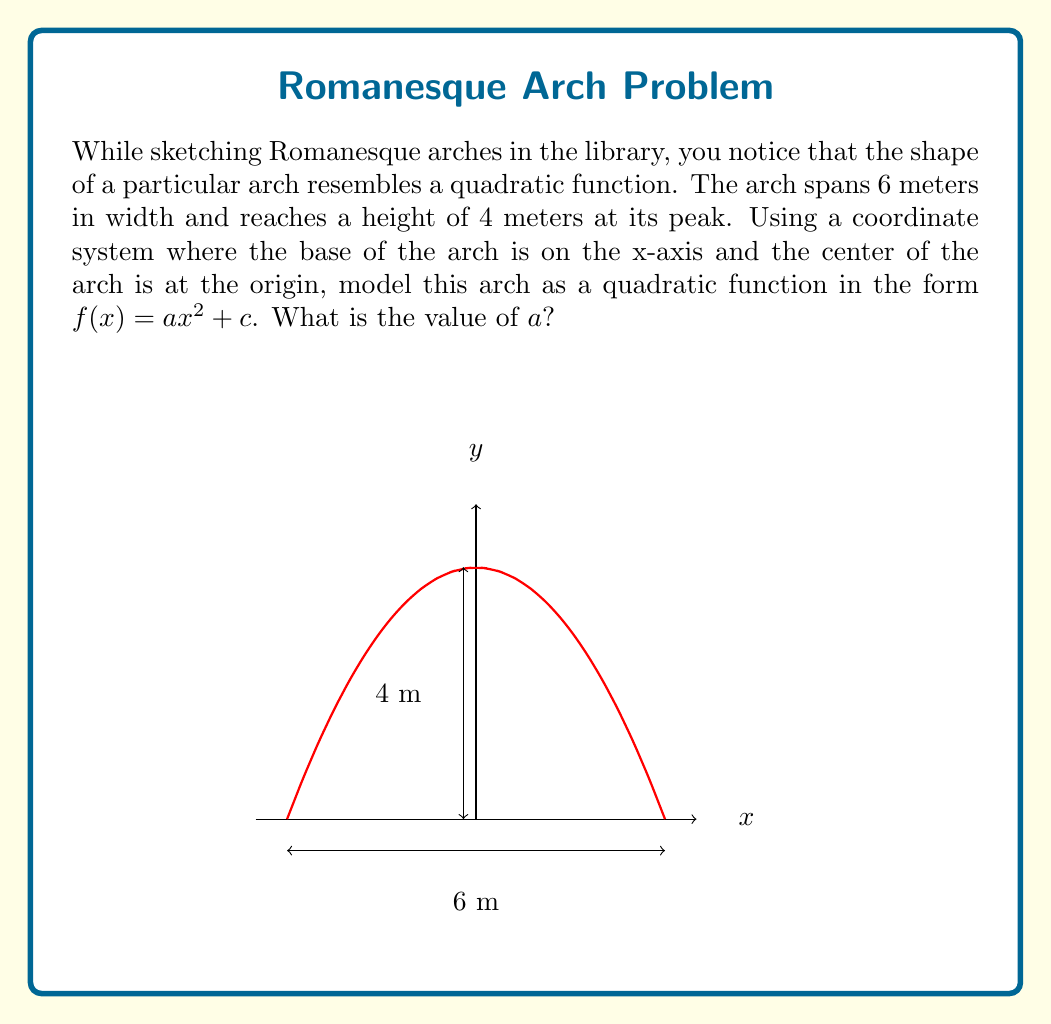Teach me how to tackle this problem. Let's approach this step-by-step:

1) The general form of a quadratic function is $f(x) = ax^2 + bx + c$. However, since the arch is symmetrical about the y-axis, we can eliminate the $bx$ term, leaving us with $f(x) = ax^2 + c$.

2) We know two key points about this arch:
   - The peak is at (0, 4), so $f(0) = 4$
   - The base spans from -3 to 3 on the x-axis, so $f(3) = f(-3) = 0$

3) Let's use the peak point (0, 4) in our equation:
   $f(0) = a(0)^2 + c = 4$
   Therefore, $c = 4$

4) Now our function is $f(x) = ax^2 + 4$

5) Let's use one of the base points, say (3, 0):
   $f(3) = a(3)^2 + 4 = 0$
   $9a + 4 = 0$
   $9a = -4$
   $a = -\frac{4}{9}$

6) We can verify this works for $x = -3$ as well:
   $f(-3) = -\frac{4}{9}(-3)^2 + 4 = -4 + 4 = 0$

Therefore, the quadratic function modeling the arch is $f(x) = -\frac{4}{9}x^2 + 4$, and the value of $a$ is $-\frac{4}{9}$.
Answer: $-\frac{4}{9}$ 